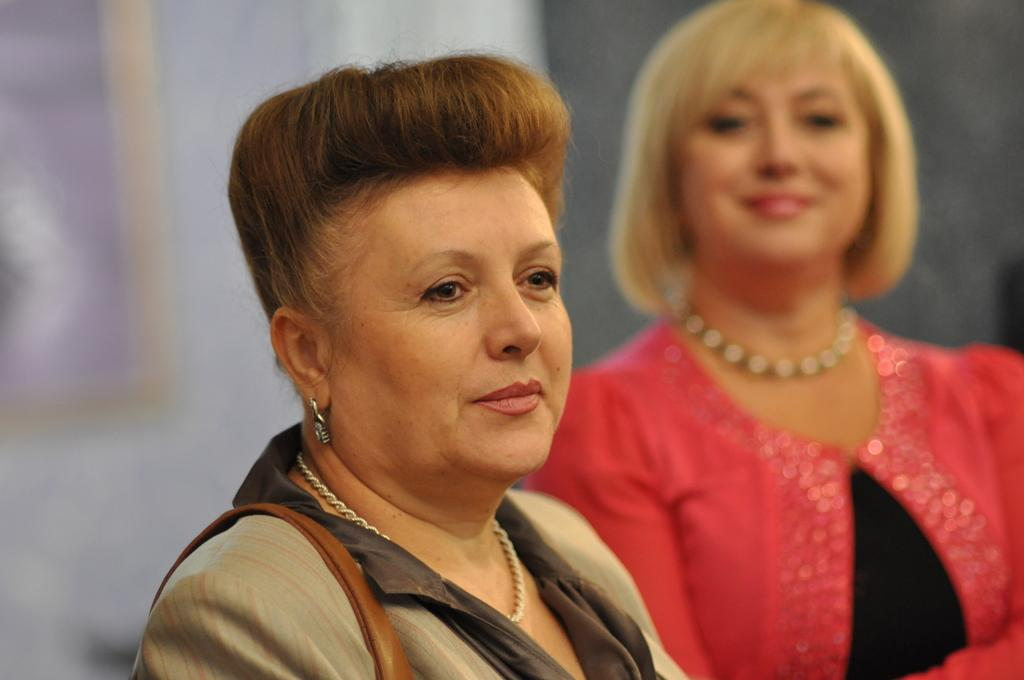How many people are in the image? There are two ladies in the image. Can you describe the appearance of the lady on the left side? The lady on the left side is wearing an earring. What can be observed about the background of the image? The background of the image is blurred. What type of branch can be seen in the hands of the giants in the image? There are no giants or branches present in the image. How many nails are visible in the image? There is no mention of nails in the provided facts, so it cannot be determined from the image. 